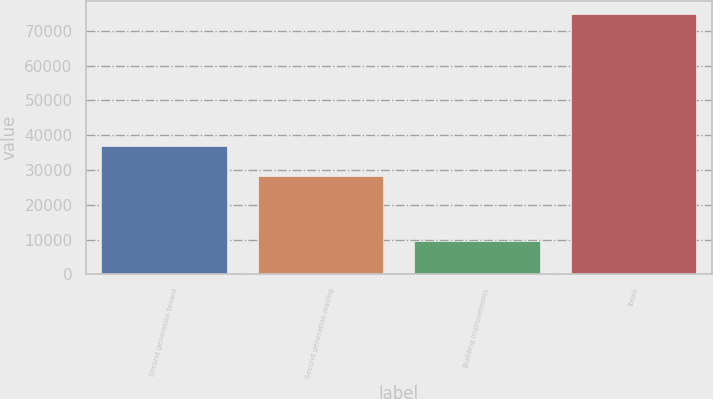Convert chart to OTSL. <chart><loc_0><loc_0><loc_500><loc_500><bar_chart><fcel>Second generation tenant<fcel>Second generation leasing<fcel>Building improvements<fcel>Totals<nl><fcel>36885<fcel>28205<fcel>9724<fcel>74814<nl></chart> 